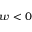Convert formula to latex. <formula><loc_0><loc_0><loc_500><loc_500>w < 0</formula> 